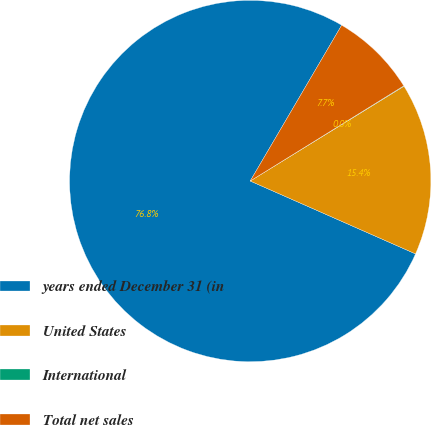Convert chart. <chart><loc_0><loc_0><loc_500><loc_500><pie_chart><fcel>years ended December 31 (in<fcel>United States<fcel>International<fcel>Total net sales<nl><fcel>76.84%<fcel>15.4%<fcel>0.04%<fcel>7.72%<nl></chart> 